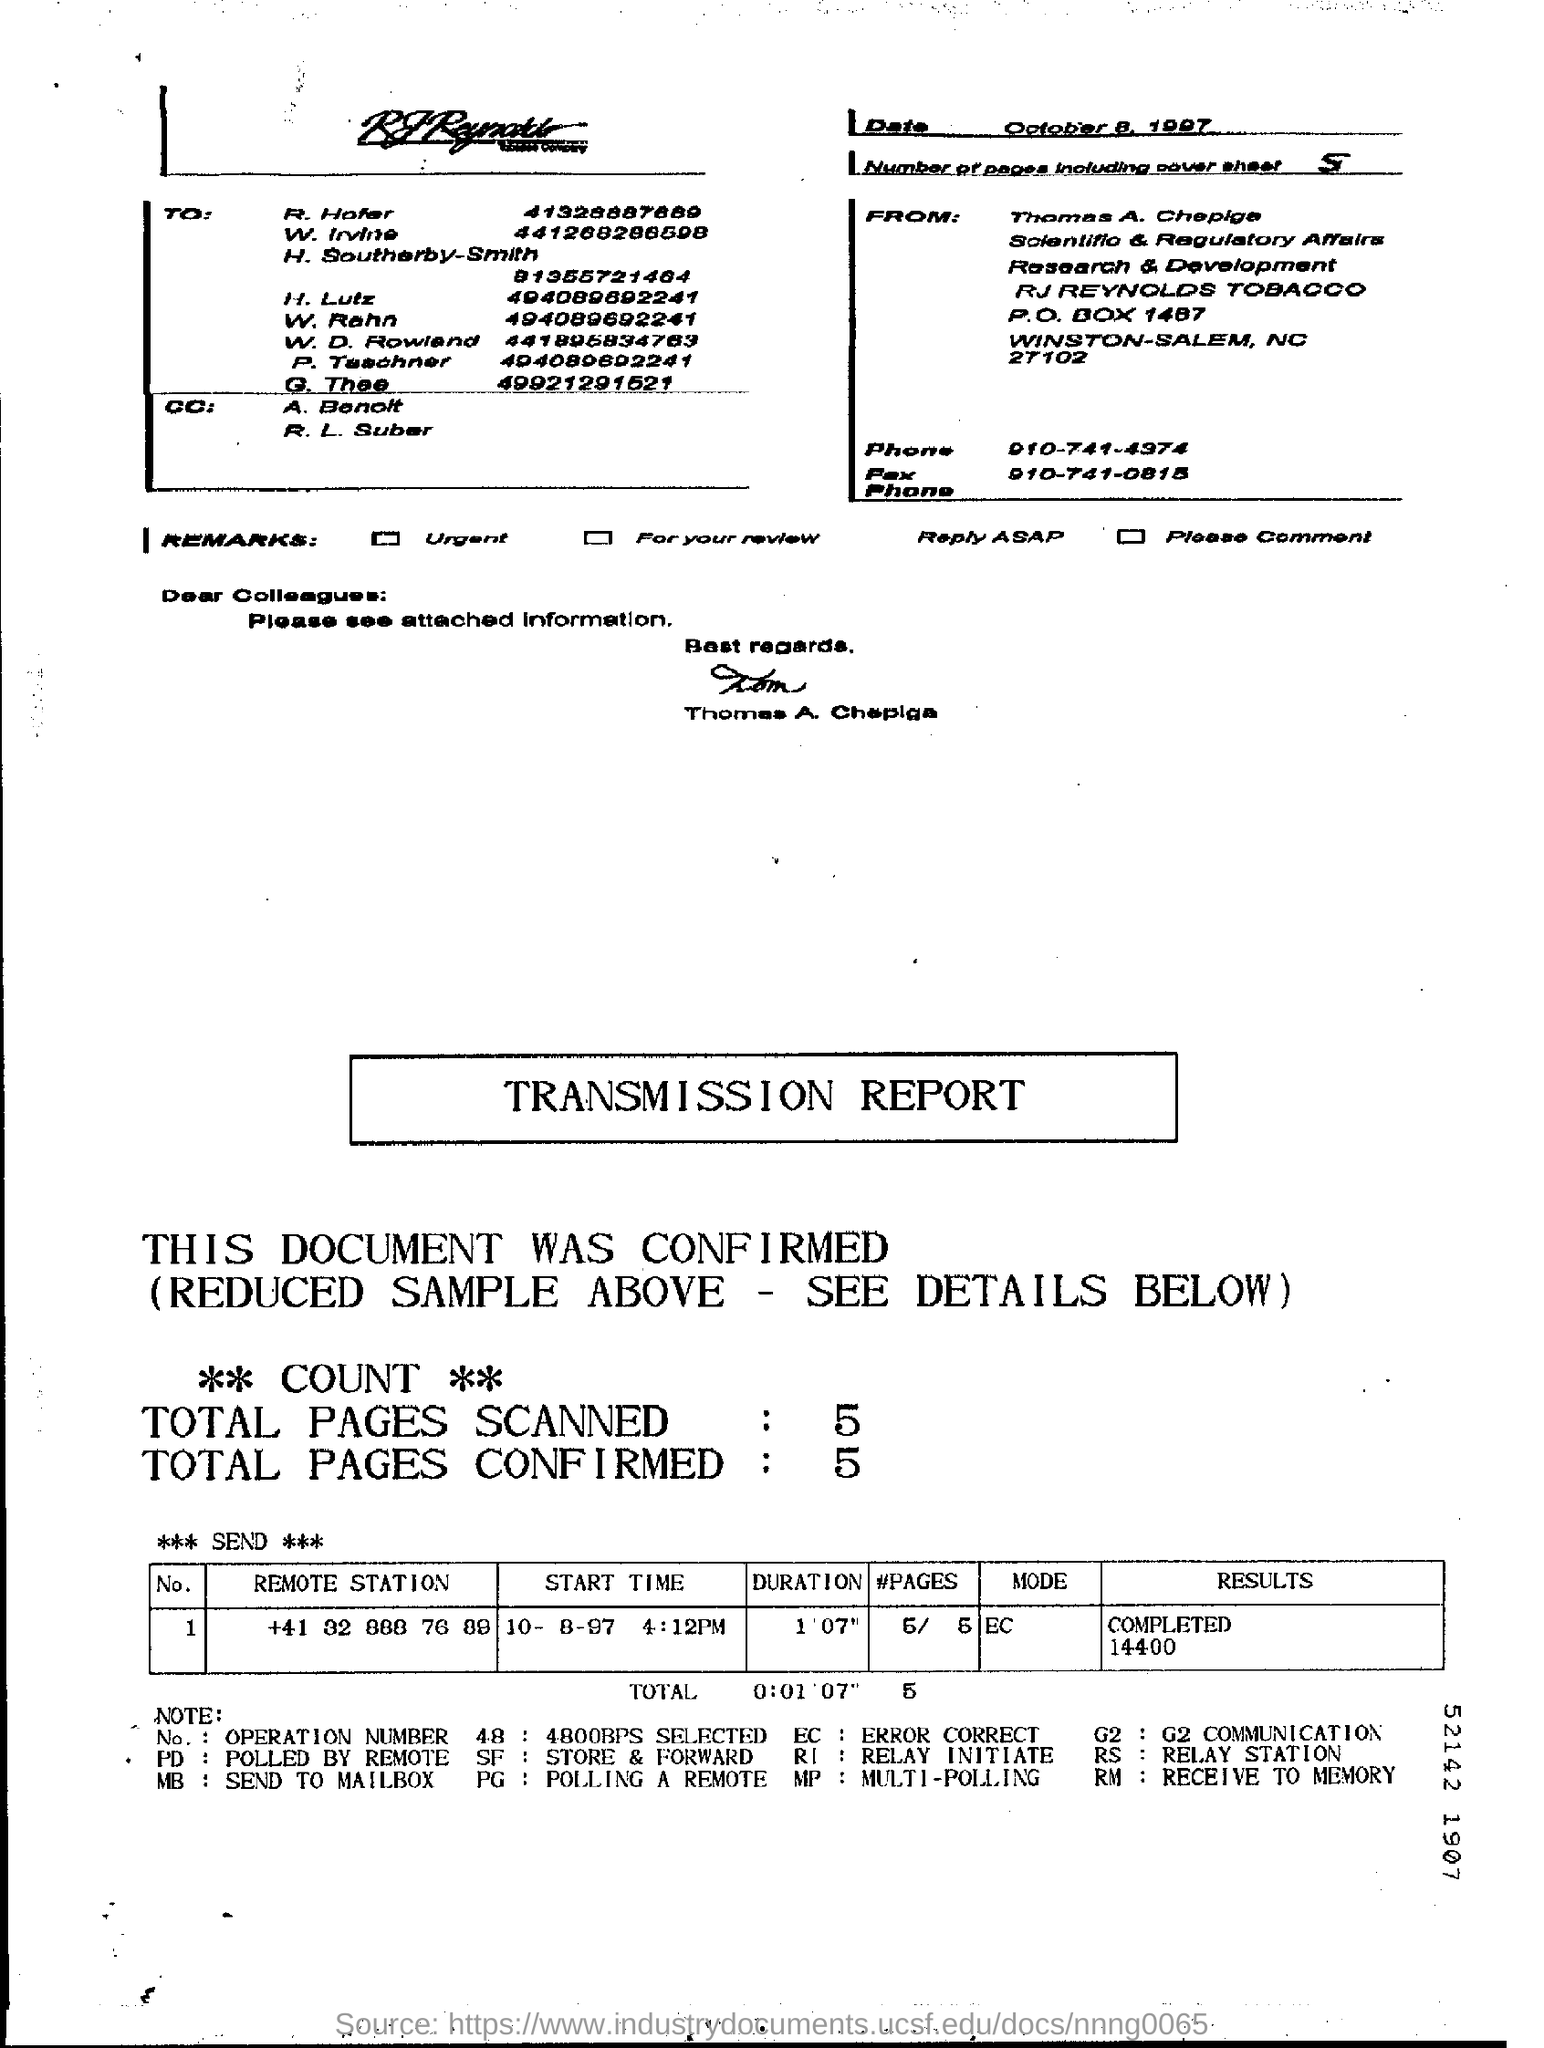Highlight a few significant elements in this photo. The mode mentioned in the transmission report is EC. The date mentioned on the page is October 8. The transmission report indicates that a total of 5 pages were scanned. There are 5 pages, including the cover sheet. The transmission report confirms a total of 5 pages. 